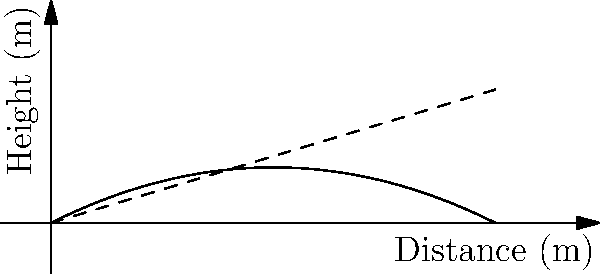As a long-range shooter, you're presented with a slope diagram showing a bullet's trajectory and the line of sight to a target. The bullet trajectory is represented by the function $f(x) = -0.05x^2 + 0.5x$, where $x$ is the distance in meters and $f(x)$ is the height in meters. The line of sight is given by $g(x) = 0.3x$. At what distance (in meters) from the shooter does the bullet reach its highest point above the line of sight? To find the distance where the bullet reaches its highest point above the line of sight, we need to follow these steps:

1) The difference between the bullet trajectory and the line of sight is given by:
   $h(x) = f(x) - g(x) = (-0.05x^2 + 0.5x) - 0.3x = -0.05x^2 + 0.2x$

2) To find the maximum of this function, we need to find where its derivative equals zero:
   $h'(x) = -0.1x + 0.2$

3) Set $h'(x) = 0$ and solve for $x$:
   $-0.1x + 0.2 = 0$
   $-0.1x = -0.2$
   $x = 2$

4) To confirm this is a maximum (not a minimum), we can check the second derivative:
   $h''(x) = -0.1$, which is negative, confirming a maximum.

5) Therefore, the bullet reaches its highest point above the line of sight at a distance of 2 meters from the shooter.
Answer: 2 meters 